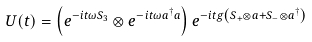<formula> <loc_0><loc_0><loc_500><loc_500>U ( t ) = \left ( e ^ { - i t \omega S _ { 3 } } \otimes e ^ { - i t \omega a ^ { \dagger } a } \right ) e ^ { - i t g \left ( S _ { + } \otimes a + S _ { - } \otimes a ^ { \dagger } \right ) }</formula> 